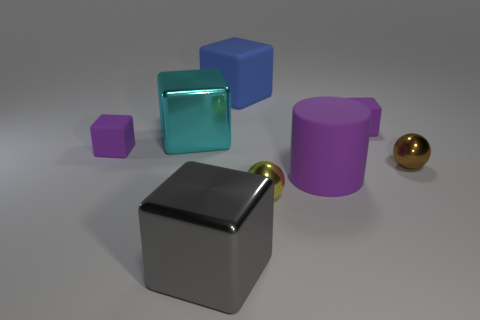Is there any object in the image that stands out due to its unique feature? Yes, the grey cube on the left stands out because it has a golden knob attached to it which contrasts with its matte texture and the simplicity of the other shapes. 